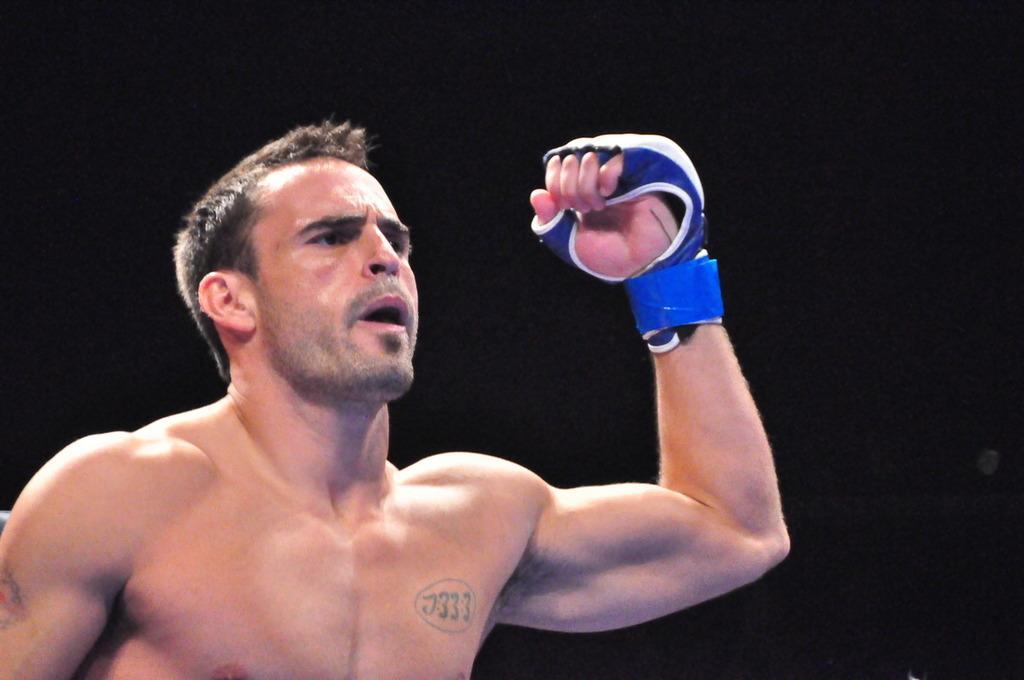Can you describe this image briefly? A man is present wearing a blue glove. There is a black background. 